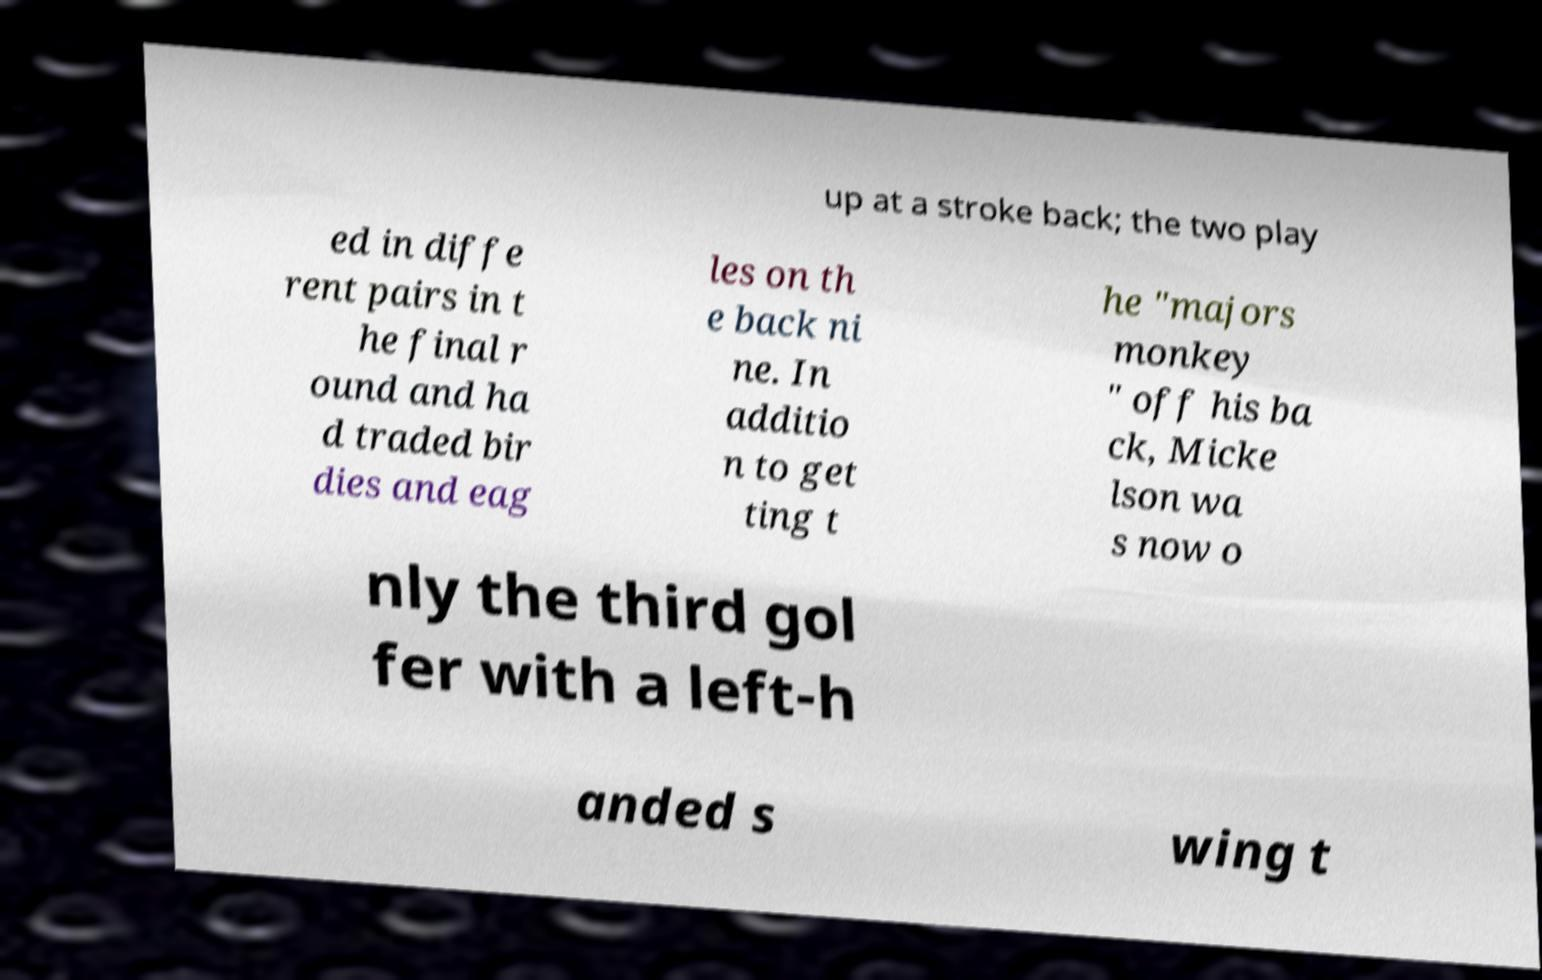Can you read and provide the text displayed in the image?This photo seems to have some interesting text. Can you extract and type it out for me? up at a stroke back; the two play ed in diffe rent pairs in t he final r ound and ha d traded bir dies and eag les on th e back ni ne. In additio n to get ting t he "majors monkey " off his ba ck, Micke lson wa s now o nly the third gol fer with a left-h anded s wing t 